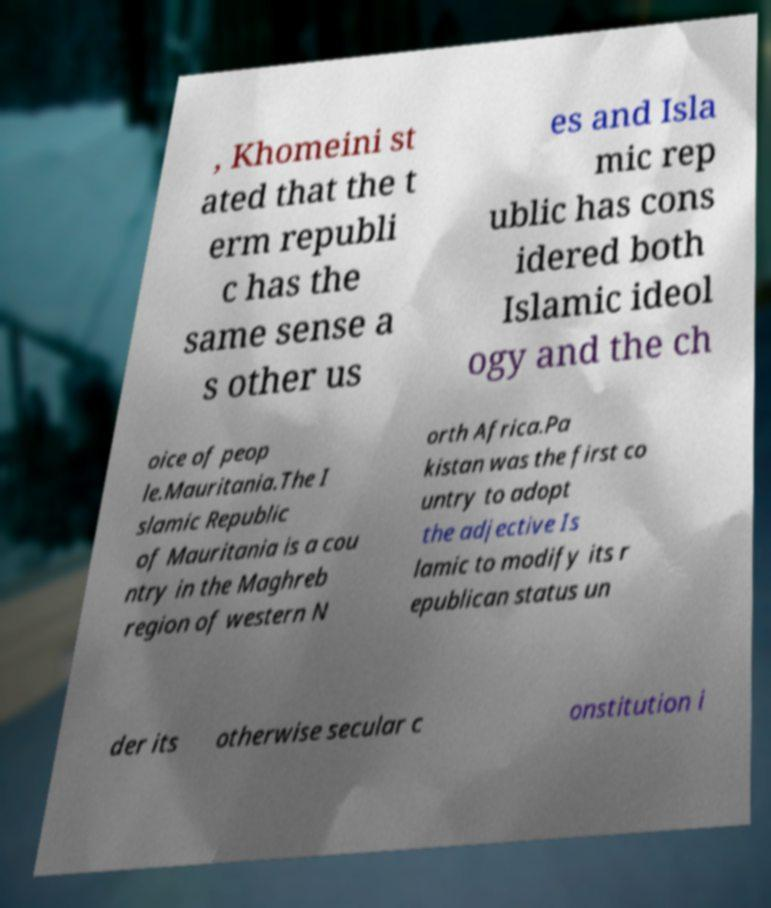Please identify and transcribe the text found in this image. , Khomeini st ated that the t erm republi c has the same sense a s other us es and Isla mic rep ublic has cons idered both Islamic ideol ogy and the ch oice of peop le.Mauritania.The I slamic Republic of Mauritania is a cou ntry in the Maghreb region of western N orth Africa.Pa kistan was the first co untry to adopt the adjective Is lamic to modify its r epublican status un der its otherwise secular c onstitution i 